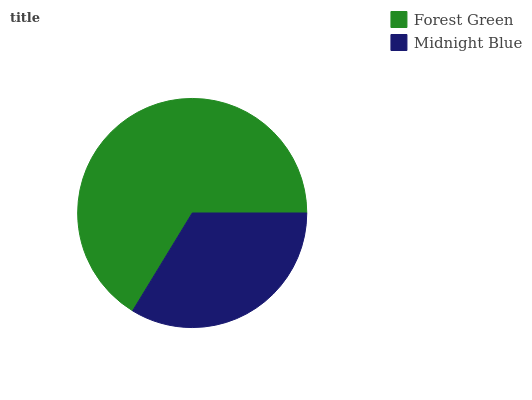Is Midnight Blue the minimum?
Answer yes or no. Yes. Is Forest Green the maximum?
Answer yes or no. Yes. Is Midnight Blue the maximum?
Answer yes or no. No. Is Forest Green greater than Midnight Blue?
Answer yes or no. Yes. Is Midnight Blue less than Forest Green?
Answer yes or no. Yes. Is Midnight Blue greater than Forest Green?
Answer yes or no. No. Is Forest Green less than Midnight Blue?
Answer yes or no. No. Is Forest Green the high median?
Answer yes or no. Yes. Is Midnight Blue the low median?
Answer yes or no. Yes. Is Midnight Blue the high median?
Answer yes or no. No. Is Forest Green the low median?
Answer yes or no. No. 